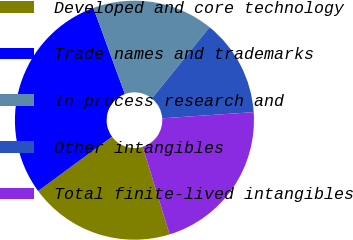<chart> <loc_0><loc_0><loc_500><loc_500><pie_chart><fcel>Developed and core technology<fcel>Trade names and trademarks<fcel>In-process research and<fcel>Other intangibles<fcel>Total finite-lived intangibles<nl><fcel>19.67%<fcel>29.51%<fcel>16.39%<fcel>13.11%<fcel>21.31%<nl></chart> 